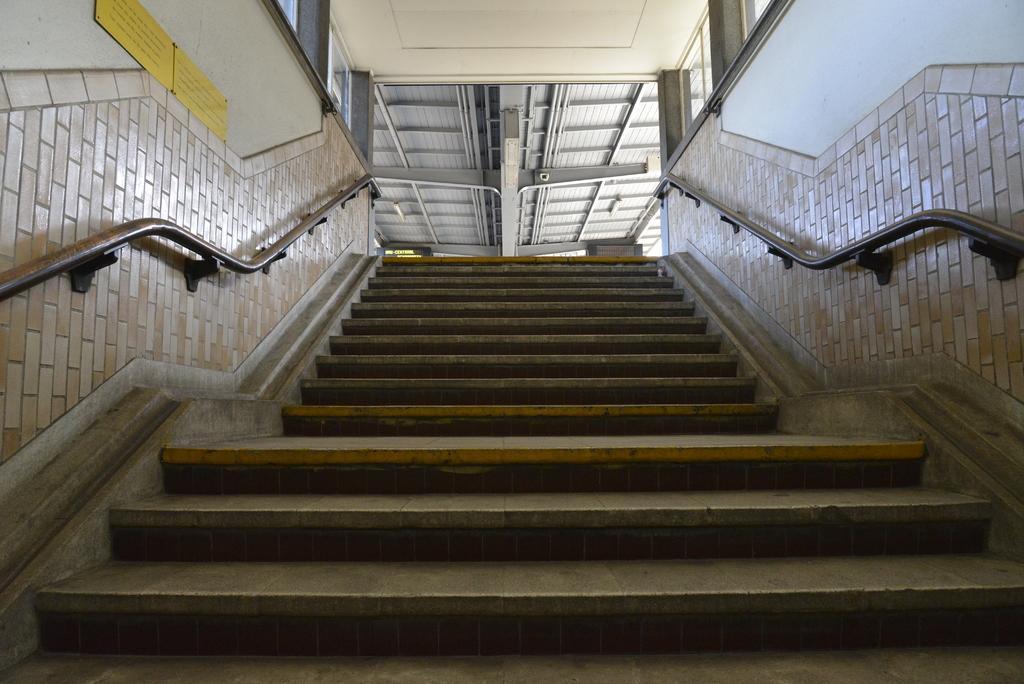Could you give a brief overview of what you see in this image? In the center of the image there is a staircase. In the background there is a wall, fences, banners, pillars and a few other objects. On the banners, we can see some text. 